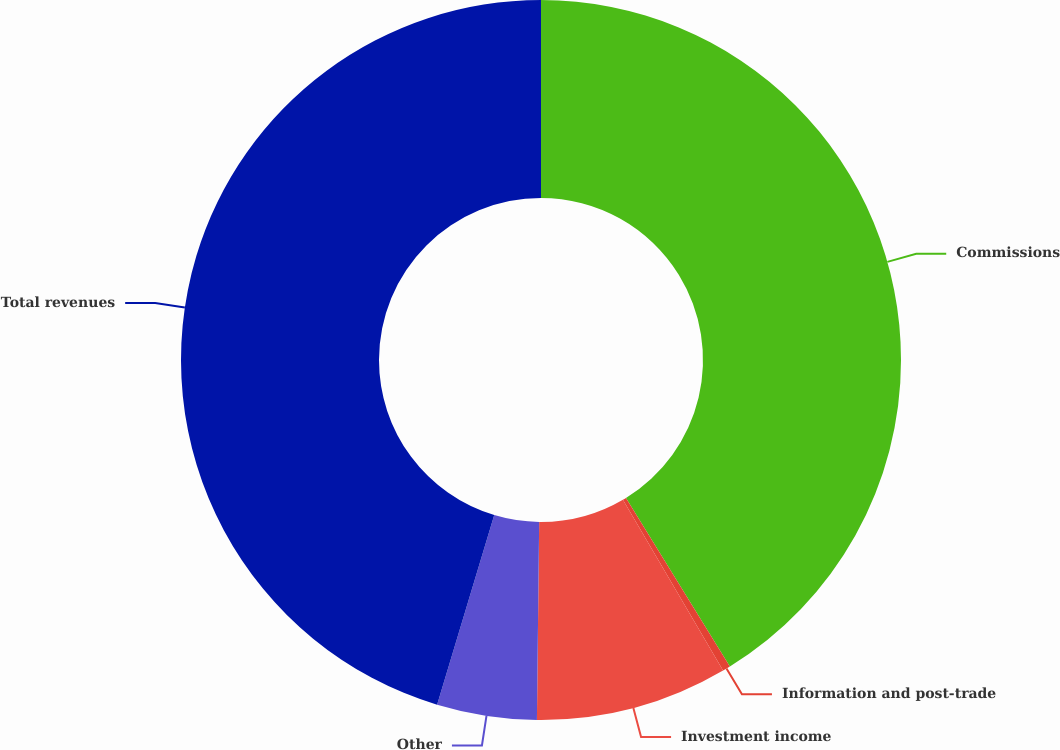<chart> <loc_0><loc_0><loc_500><loc_500><pie_chart><fcel>Commissions<fcel>Information and post-trade<fcel>Investment income<fcel>Other<fcel>Total revenues<nl><fcel>41.21%<fcel>0.35%<fcel>8.62%<fcel>4.48%<fcel>45.34%<nl></chart> 